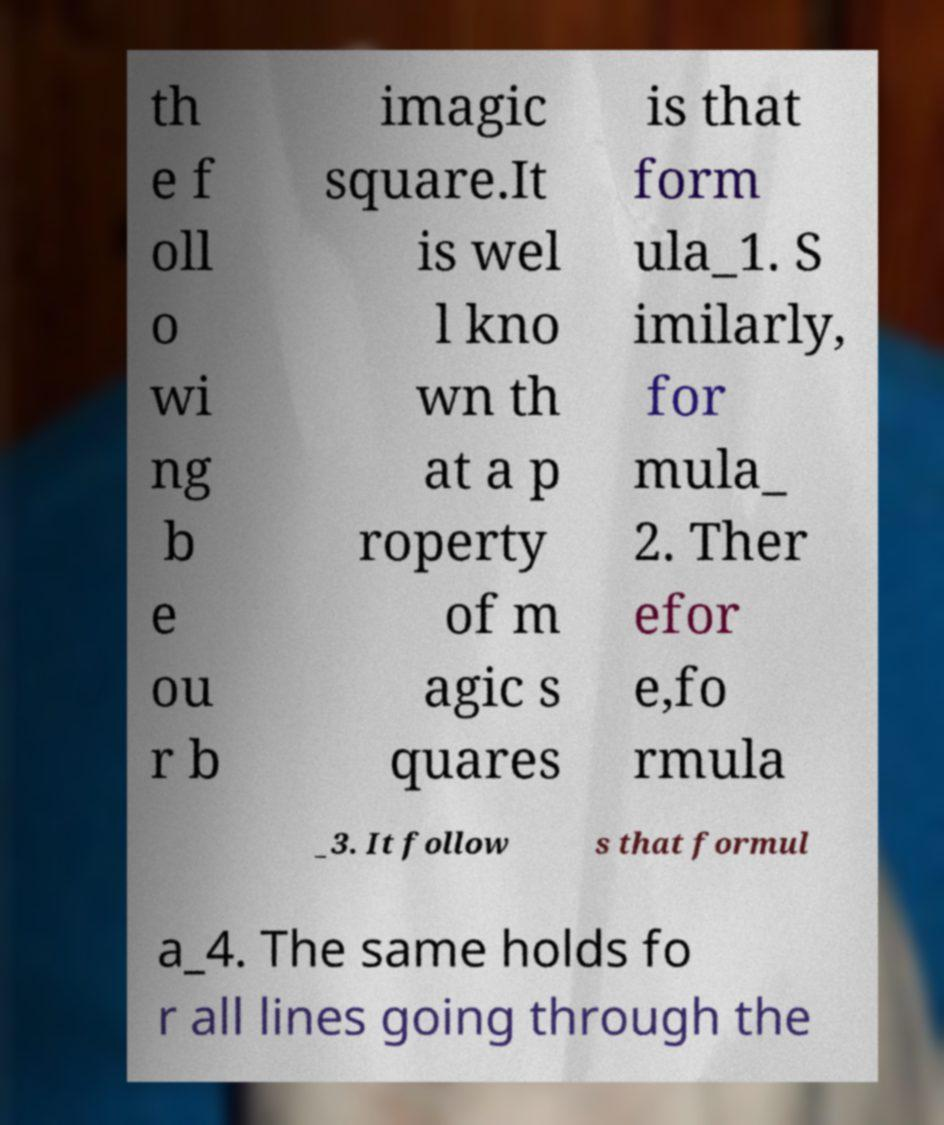Can you read and provide the text displayed in the image?This photo seems to have some interesting text. Can you extract and type it out for me? th e f oll o wi ng b e ou r b imagic square.It is wel l kno wn th at a p roperty of m agic s quares is that form ula_1. S imilarly, for mula_ 2. Ther efor e,fo rmula _3. It follow s that formul a_4. The same holds fo r all lines going through the 